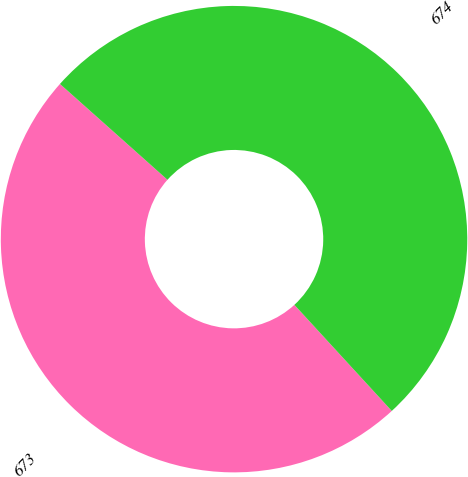<chart> <loc_0><loc_0><loc_500><loc_500><pie_chart><fcel>673<fcel>674<nl><fcel>48.41%<fcel>51.59%<nl></chart> 